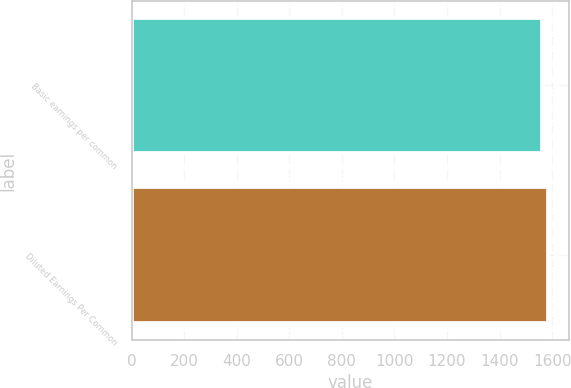Convert chart to OTSL. <chart><loc_0><loc_0><loc_500><loc_500><bar_chart><fcel>Basic earnings per common<fcel>Diluted Earnings Per Common<nl><fcel>1560<fcel>1584<nl></chart> 